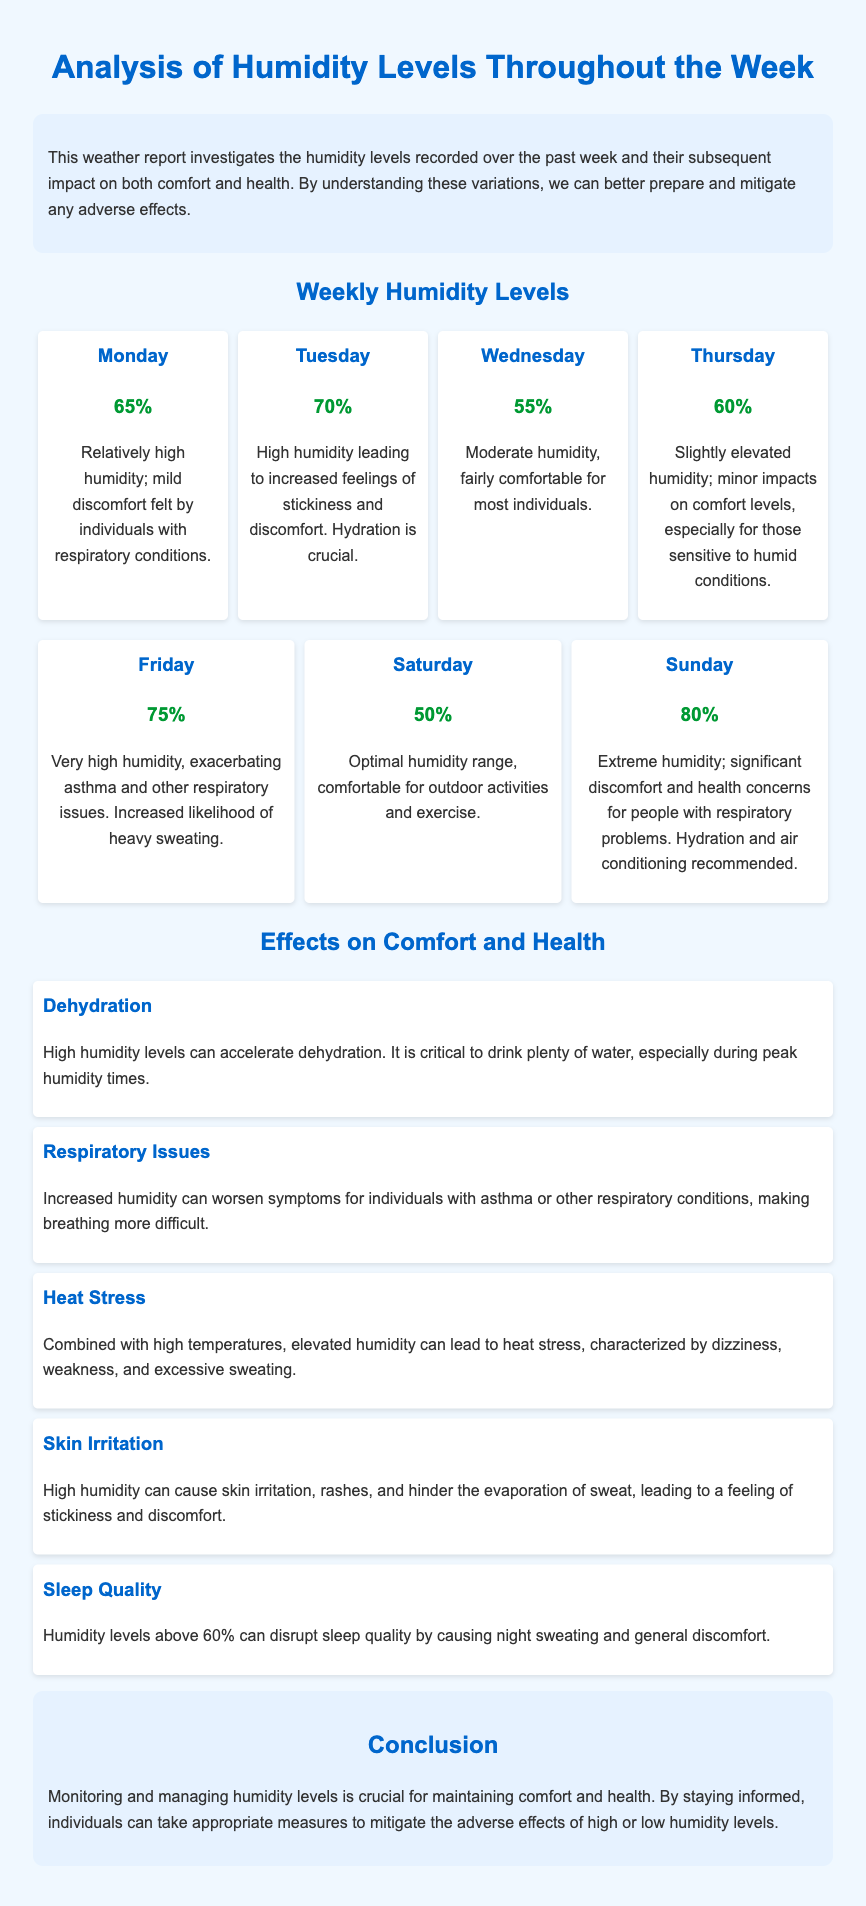What was the humidity level on Tuesday? The humidity level on Tuesday is mentioned in the document as 70%.
Answer: 70% Which day had the lowest humidity? The document specifies that Saturday had the lowest humidity at 50%.
Answer: Saturday What discomfort did people experience on Friday? The report explains that very high humidity on Friday exacerbated asthma and other respiratory issues.
Answer: Asthma What can be a consequence of high humidity according to the report? The document lists dehydration as a consequence of high humidity levels.
Answer: Dehydration On which day is hydration particularly recommended? The report recommends hydration on days with extreme humidity, specifically mentioned for Sunday.
Answer: Sunday How does humidity above 60% affect sleep quality? The document states that humidity levels above 60% can disrupt sleep quality due to discomfort.
Answer: Disrupt sleep quality What was the humidity level on Wednesday? The humidity level on Wednesday is noted as 55% in the report.
Answer: 55% What does the report suggest for individuals with respiratory issues during high humidity? The report advises hydration and air conditioning for people with respiratory issues during high humidity levels.
Answer: Hydration and air conditioning 